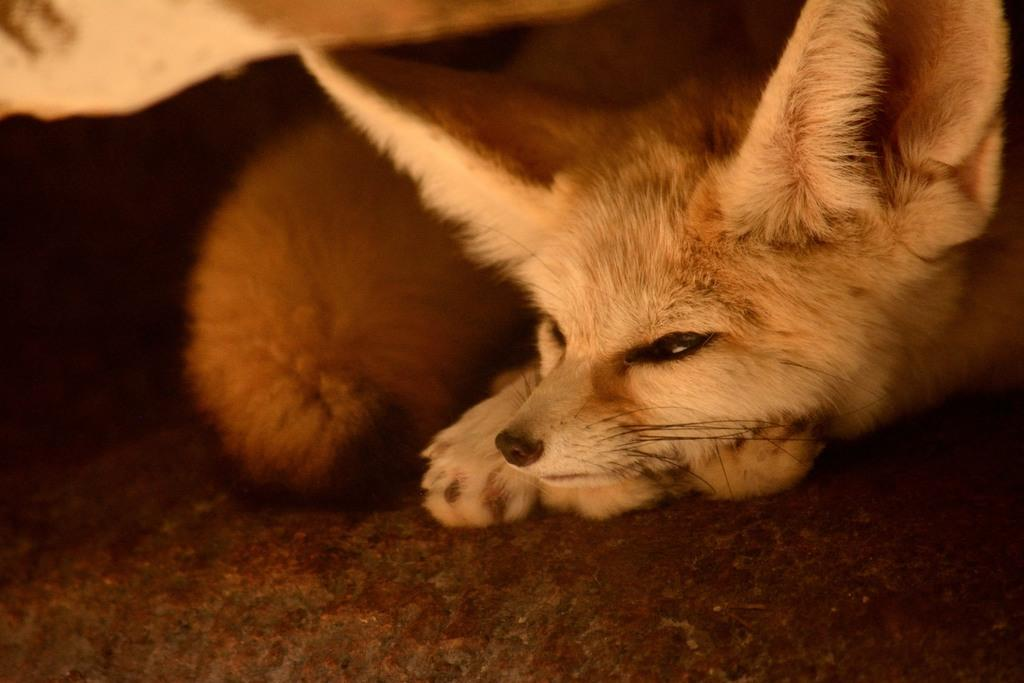What animal is present in the image? There is a dog in the image. What is the dog doing in the image? The dog is laying on the floor. What can be observed about the background of the image? The background of the image is dark. What type of appliance is the dog using in the image? There is no appliance present in the image, and the dog is not using any appliance. What type of authority figure is depicted in the image? There is no authority figure depicted in the image; it features a dog laying on the floor. 